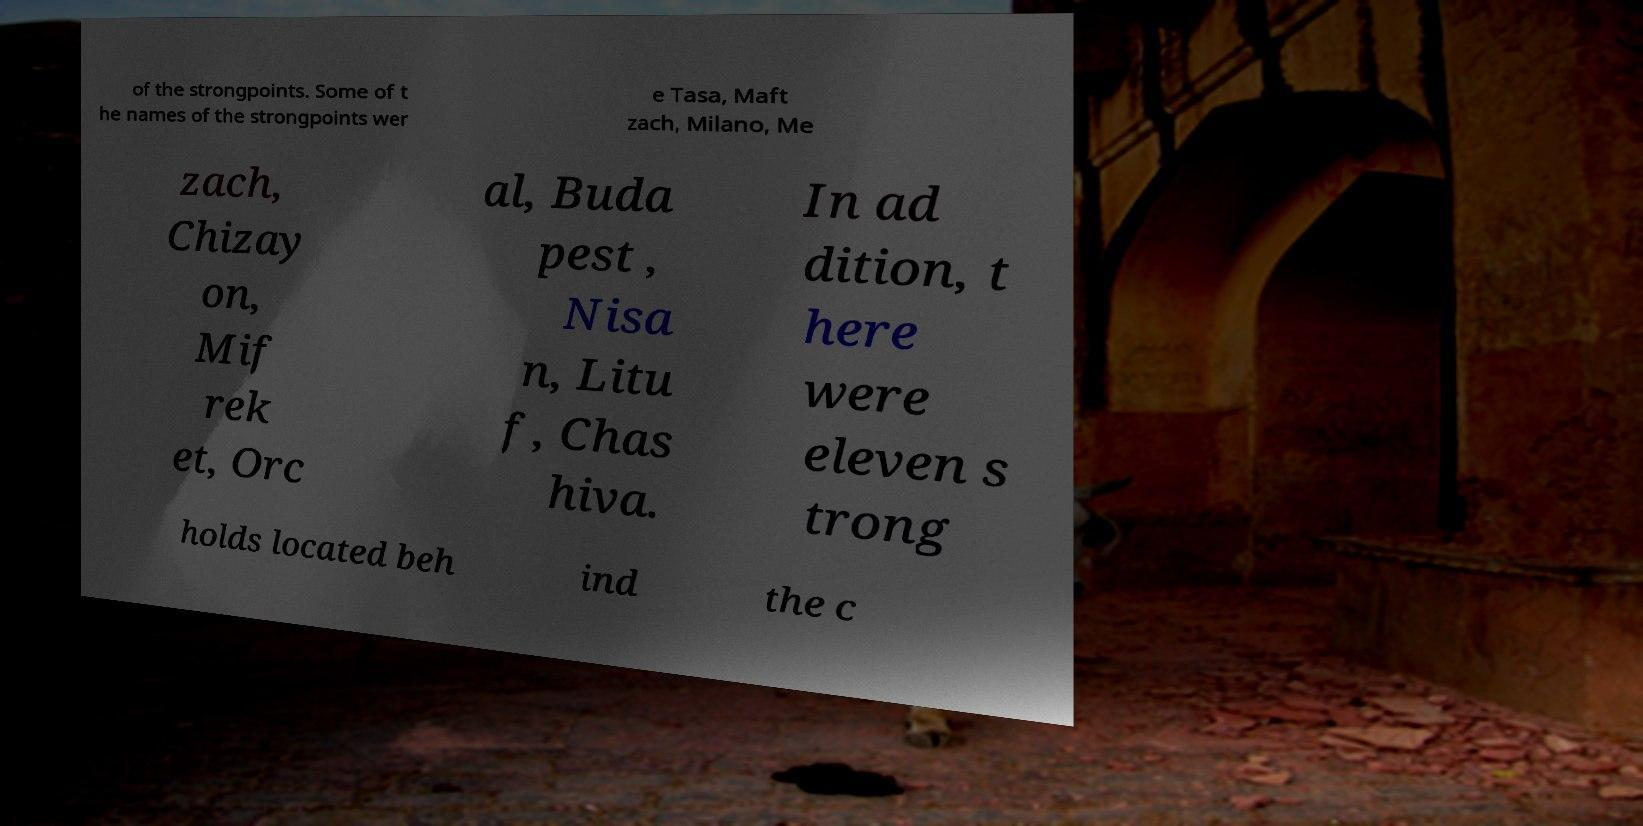I need the written content from this picture converted into text. Can you do that? of the strongpoints. Some of t he names of the strongpoints wer e Tasa, Maft zach, Milano, Me zach, Chizay on, Mif rek et, Orc al, Buda pest , Nisa n, Litu f, Chas hiva. In ad dition, t here were eleven s trong holds located beh ind the c 